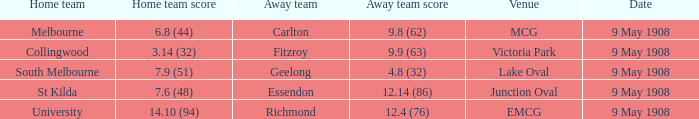Could you parse the entire table as a dict? {'header': ['Home team', 'Home team score', 'Away team', 'Away team score', 'Venue', 'Date'], 'rows': [['Melbourne', '6.8 (44)', 'Carlton', '9.8 (62)', 'MCG', '9 May 1908'], ['Collingwood', '3.14 (32)', 'Fitzroy', '9.9 (63)', 'Victoria Park', '9 May 1908'], ['South Melbourne', '7.9 (51)', 'Geelong', '4.8 (32)', 'Lake Oval', '9 May 1908'], ['St Kilda', '7.6 (48)', 'Essendon', '12.14 (86)', 'Junction Oval', '9 May 1908'], ['University', '14.10 (94)', 'Richmond', '12.4 (76)', 'EMCG', '9 May 1908']]} Name the home team for carlton away team Melbourne. 